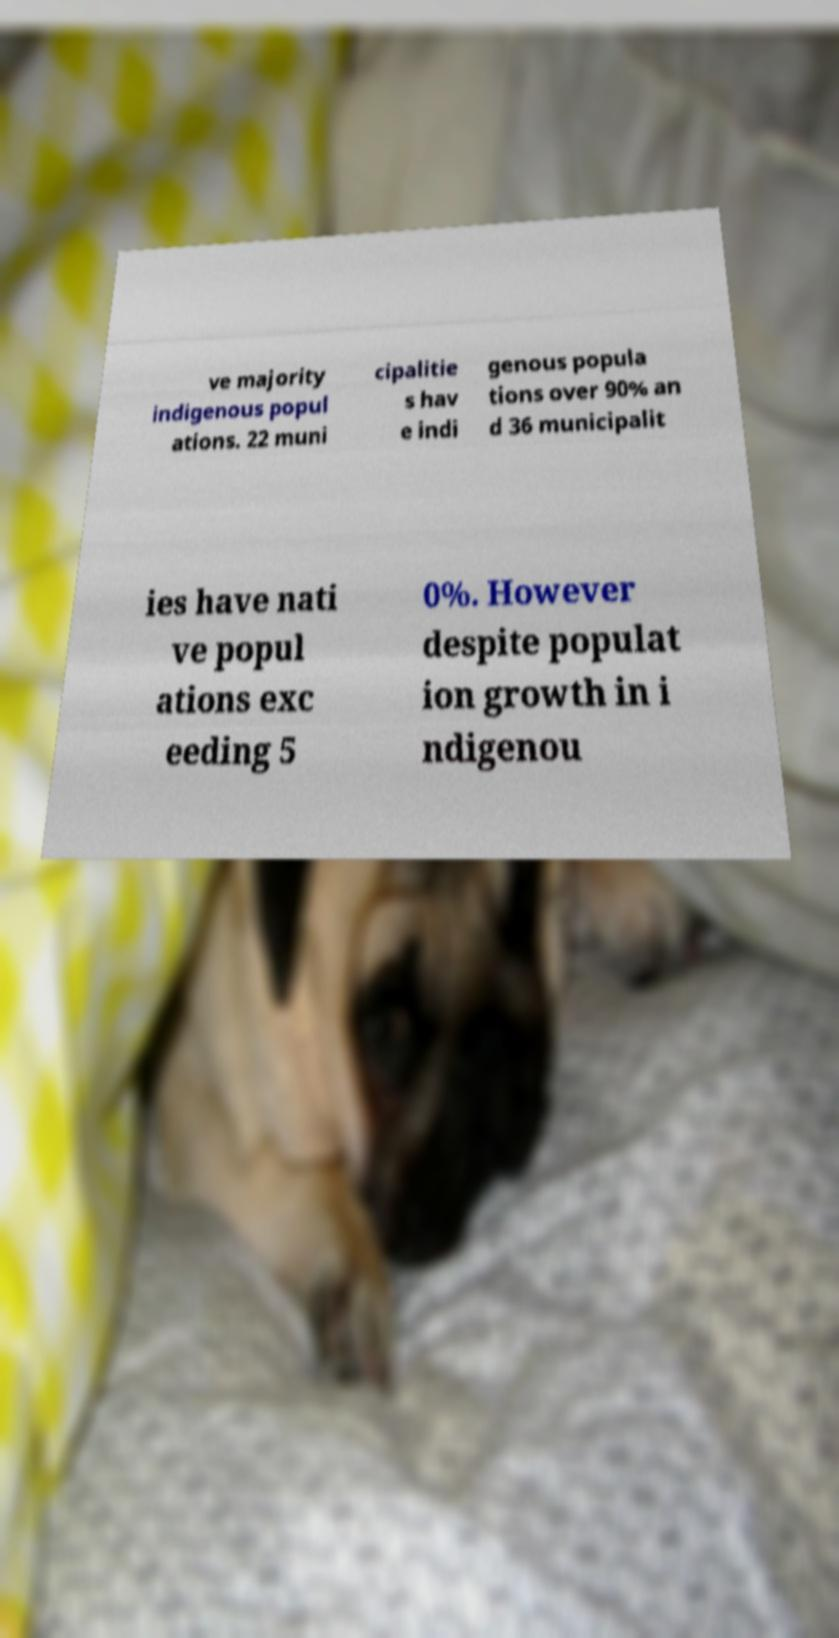Can you read and provide the text displayed in the image?This photo seems to have some interesting text. Can you extract and type it out for me? ve majority indigenous popul ations. 22 muni cipalitie s hav e indi genous popula tions over 90% an d 36 municipalit ies have nati ve popul ations exc eeding 5 0%. However despite populat ion growth in i ndigenou 